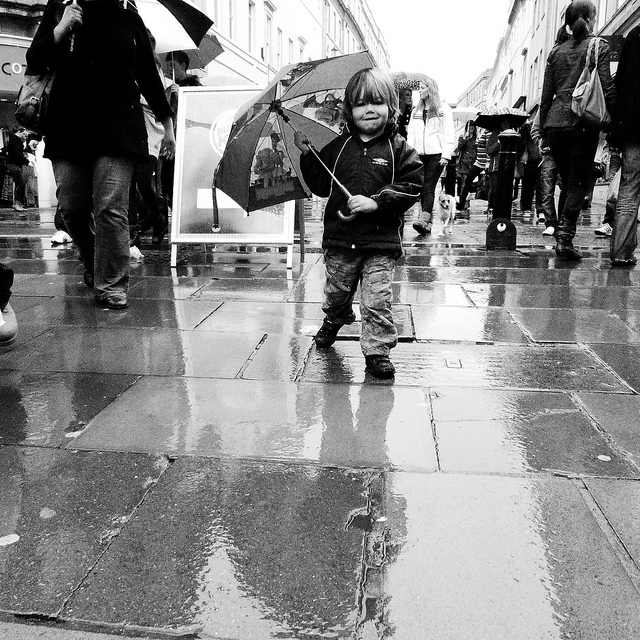Please identify all text content in this image. CO 